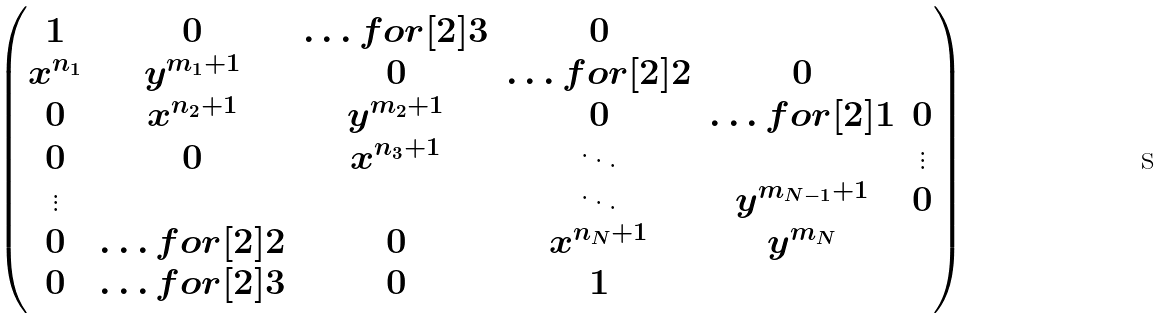<formula> <loc_0><loc_0><loc_500><loc_500>\begin{pmatrix} 1 & 0 & \hdots f o r [ 2 ] { 3 } & 0 \\ x ^ { n _ { 1 } } & y ^ { m _ { 1 } + 1 } & 0 & \hdots f o r [ 2 ] { 2 } & 0 \\ 0 & x ^ { n _ { 2 } + 1 } & y ^ { m _ { 2 } + 1 } & 0 & \hdots f o r [ 2 ] { 1 } & 0 \\ 0 & 0 & x ^ { n _ { 3 } + 1 } & \ddots & & \vdots \\ \vdots & & & \ddots & y ^ { m _ { N - 1 } + 1 } & 0 \\ 0 & \hdots f o r [ 2 ] { 2 } & 0 & x ^ { n _ { N } + 1 } & y ^ { m _ { N } } \\ 0 & \hdots f o r [ 2 ] { 3 } & 0 & 1 \end{pmatrix}</formula> 